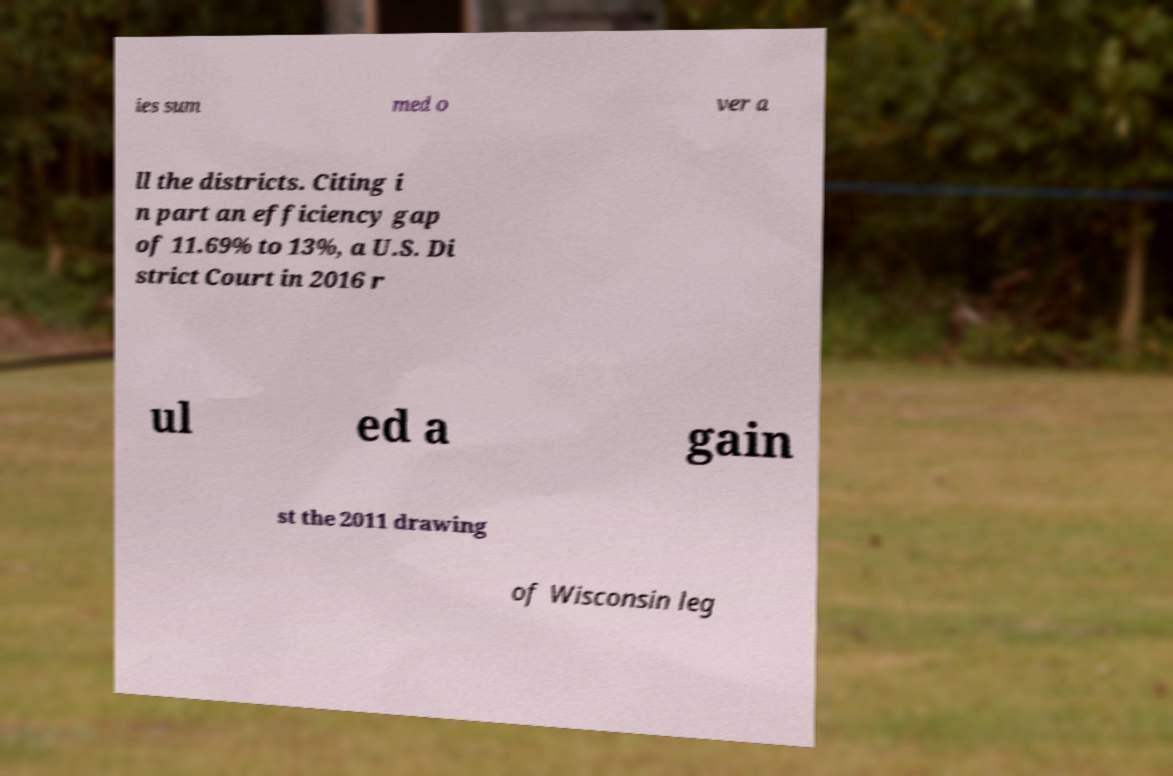I need the written content from this picture converted into text. Can you do that? ies sum med o ver a ll the districts. Citing i n part an efficiency gap of 11.69% to 13%, a U.S. Di strict Court in 2016 r ul ed a gain st the 2011 drawing of Wisconsin leg 